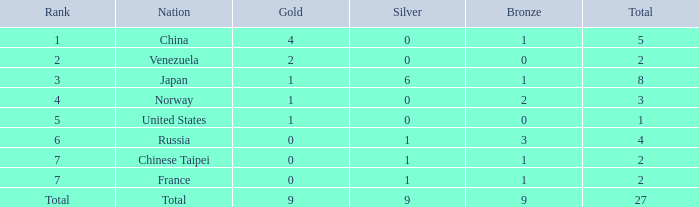What is the Nation when there is a total less than 27, gold is less than 1, and bronze is more than 1? Russia. 